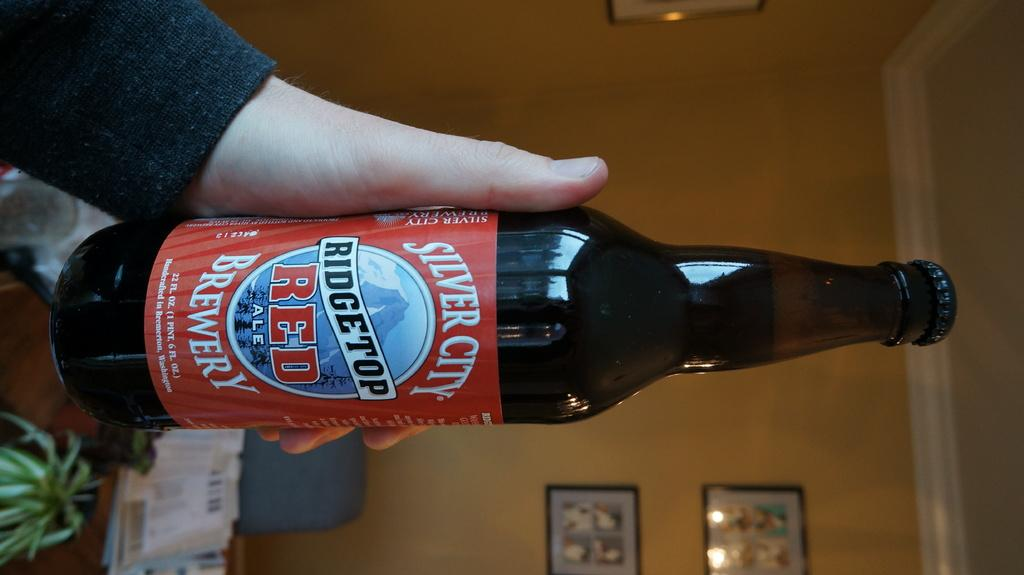<image>
Render a clear and concise summary of the photo. a bottle of beer reading silver city on a red label 